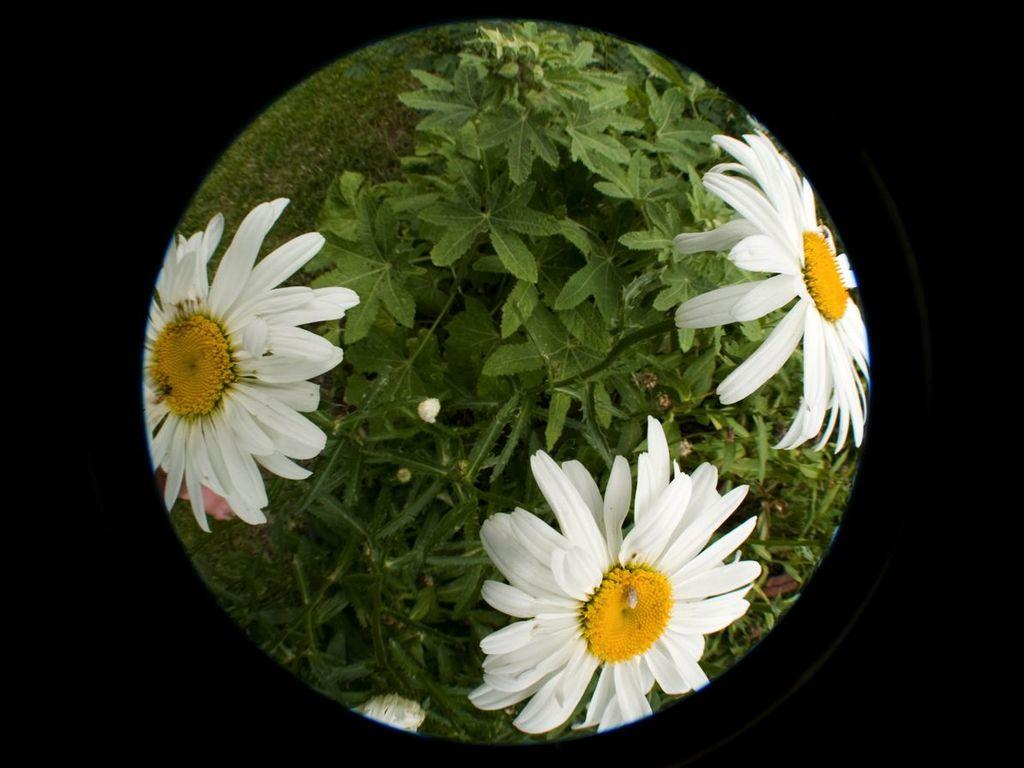What type of living organism can be seen in the image? There is a plant in the image. How many flowers are on the plant in the image? The plant has three white flowers. What type of vegetation is visible in the image besides the plant? There is grass in the image. Where is the lunchroom located in the image? There is no mention of a lunchroom in the image; it features a plant with three white flowers and grass. Are there any giants visible in the image? There are no giants present in the image. 